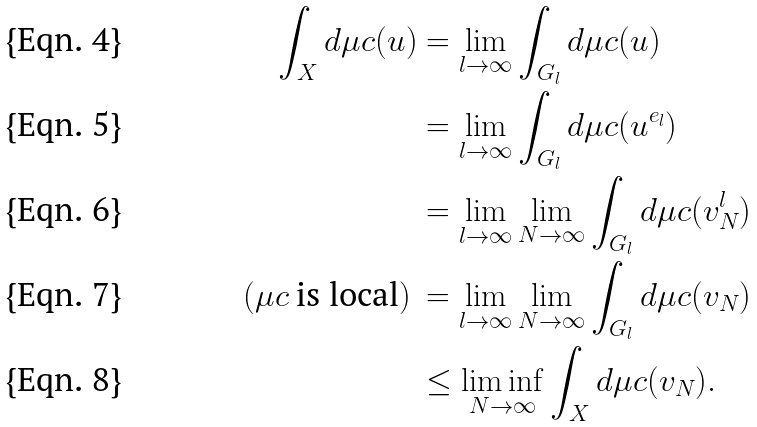Convert formula to latex. <formula><loc_0><loc_0><loc_500><loc_500>\int _ { X } d \mu c ( u ) & = \lim _ { l \to \infty } \int _ { G _ { l } } d \mu c ( u ) \\ & = \lim _ { l \to \infty } \int _ { G _ { l } } d \mu c ( u ^ { e _ { l } } ) \\ & = \lim _ { l \to \infty } \lim _ { N \to \infty } \int _ { G _ { l } } d \mu c ( v _ { N } ^ { l } ) \\ ( \mu c \text { is local} ) \, & = \lim _ { l \to \infty } \lim _ { N \to \infty } \int _ { G _ { l } } d \mu c ( v _ { N } ) \\ & \leq \liminf _ { N \to \infty } \int _ { X } d \mu c ( v _ { N } ) .</formula> 